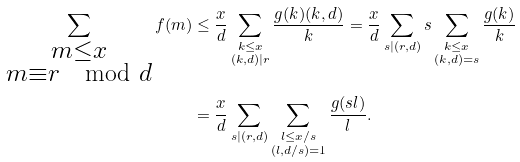<formula> <loc_0><loc_0><loc_500><loc_500>\sum _ { \substack { m \leq x \\ m \equiv r \mod { d } } } f ( m ) & \leq \frac { x } { d } \sum _ { \substack { k \leq x \\ ( k , d ) | r } } \frac { g ( k ) ( k , d ) } { k } = \frac { x } { d } \sum _ { s | ( r , d ) } s \sum _ { \substack { k \leq x \\ ( k , d ) = s } } \frac { g ( k ) } { k } \\ & = \frac { x } { d } \sum _ { s | ( r , d ) } \sum _ { \substack { l \leq x / s \\ ( l , d / s ) = 1 } } \frac { g ( s l ) } { l } .</formula> 